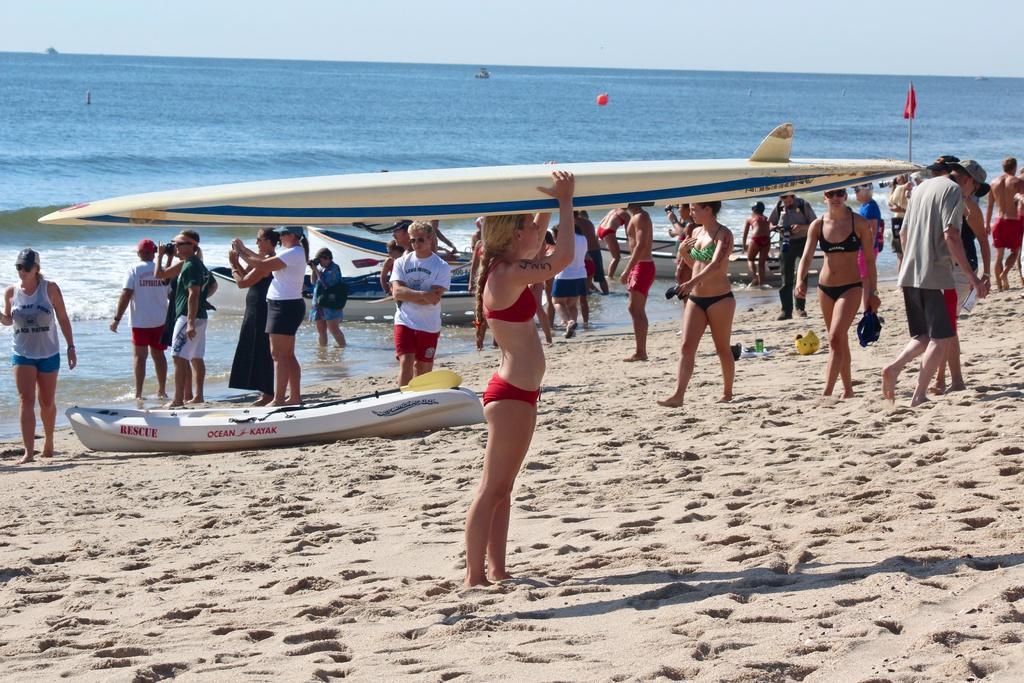Please provide a concise description of this image. In this image I can see the sea , in front of sea I can see boats and group of persons, in the foreground I can see a woman holding a ski board on her head. 